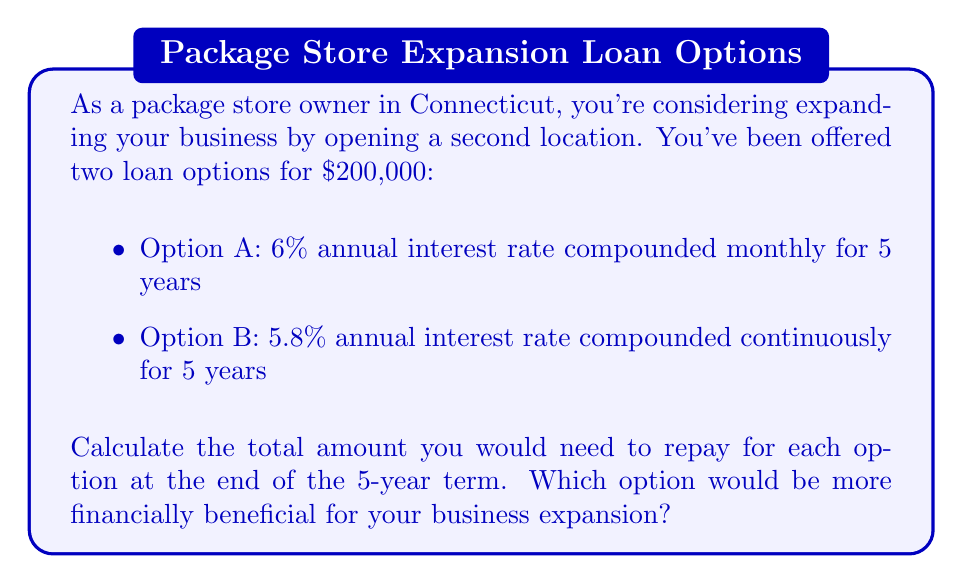What is the answer to this math problem? To solve this problem, we need to calculate the future value of each loan option after 5 years.

For Option A:
We use the compound interest formula:
$$A = P(1 + \frac{r}{n})^{nt}$$
Where:
$A$ = final amount
$P$ = principal (initial loan amount)
$r$ = annual interest rate
$n$ = number of times interest is compounded per year
$t$ = number of years

Given:
$P = \$200,000$
$r = 6\% = 0.06$
$n = 12$ (compounded monthly)
$t = 5$ years

$$A = 200,000(1 + \frac{0.06}{12})^{12 \cdot 5}$$
$$A = 200,000(1.005)^{60}$$
$$A = 200,000 \cdot 1.3488$$
$$A = \$269,760.00$$

For Option B:
We use the continuous compound interest formula:
$$A = Pe^{rt}$$
Where:
$e$ is the mathematical constant (approximately 2.71828)

Given:
$P = \$200,000$
$r = 5.8\% = 0.058$
$t = 5$ years

$$A = 200,000e^{0.058 \cdot 5}$$
$$A = 200,000e^{0.29}$$
$$A = 200,000 \cdot 1.3364$$
$$A = \$267,280.00$$
Answer: Option A total repayment: $269,760.00
Option B total repayment: $267,280.00

Option B (5.8% interest compounded continuously) is more financially beneficial for the business expansion, as it results in a lower total repayment amount, saving $2,480.00 compared to Option A. 